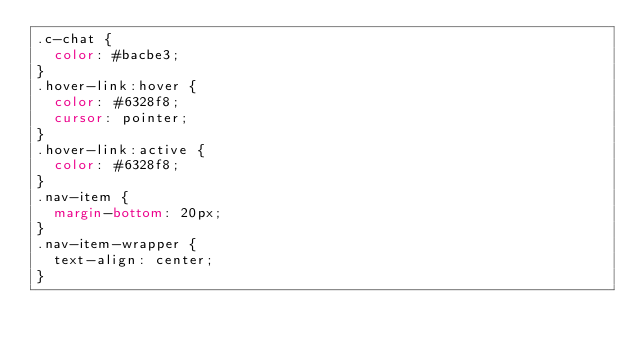Convert code to text. <code><loc_0><loc_0><loc_500><loc_500><_CSS_>.c-chat {
  color: #bacbe3;
}
.hover-link:hover {
  color: #6328f8;
  cursor: pointer;
}
.hover-link:active {
  color: #6328f8;
}
.nav-item {
  margin-bottom: 20px;
}
.nav-item-wrapper {
  text-align: center;
}
</code> 